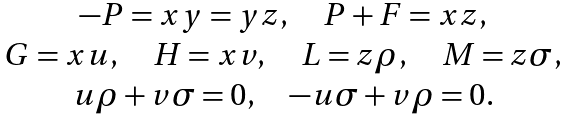Convert formula to latex. <formula><loc_0><loc_0><loc_500><loc_500>\begin{array} { c } - P = x y = y z , \quad P + F = x z , \\ G = x u , \quad H = x v , \quad L = z \rho , \quad M = z \sigma , \\ u \rho + v \sigma = 0 , \quad - u \sigma + v \rho = 0 . \end{array}</formula> 